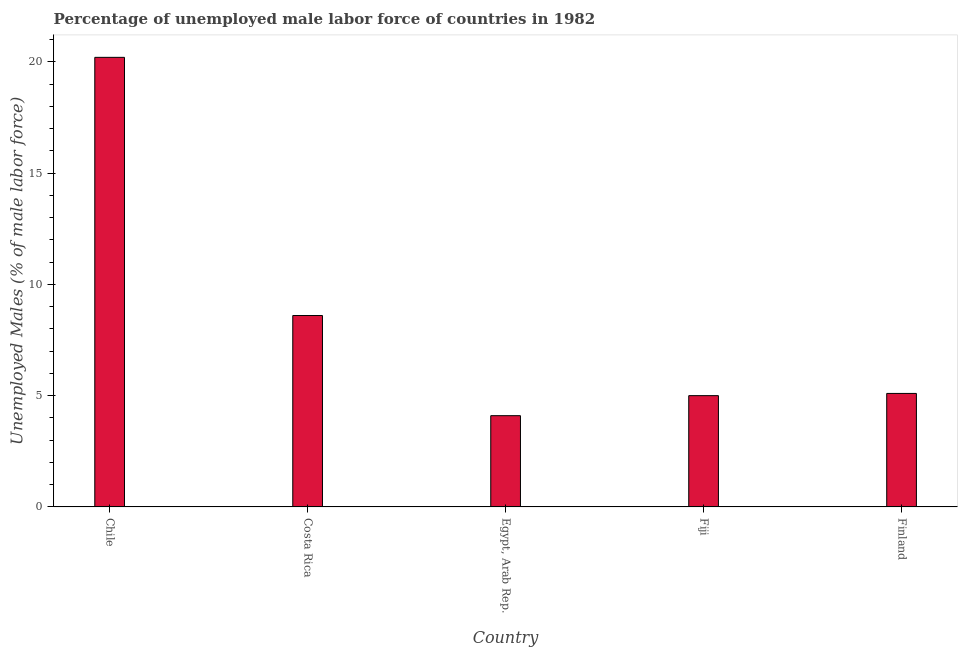Does the graph contain any zero values?
Offer a terse response. No. What is the title of the graph?
Provide a succinct answer. Percentage of unemployed male labor force of countries in 1982. What is the label or title of the X-axis?
Give a very brief answer. Country. What is the label or title of the Y-axis?
Make the answer very short. Unemployed Males (% of male labor force). What is the total unemployed male labour force in Finland?
Your answer should be compact. 5.1. Across all countries, what is the maximum total unemployed male labour force?
Your answer should be compact. 20.2. Across all countries, what is the minimum total unemployed male labour force?
Offer a very short reply. 4.1. In which country was the total unemployed male labour force minimum?
Keep it short and to the point. Egypt, Arab Rep. What is the sum of the total unemployed male labour force?
Keep it short and to the point. 43. What is the difference between the total unemployed male labour force in Chile and Egypt, Arab Rep.?
Give a very brief answer. 16.1. What is the average total unemployed male labour force per country?
Offer a terse response. 8.6. What is the median total unemployed male labour force?
Make the answer very short. 5.1. In how many countries, is the total unemployed male labour force greater than 6 %?
Provide a short and direct response. 2. What is the ratio of the total unemployed male labour force in Chile to that in Egypt, Arab Rep.?
Provide a succinct answer. 4.93. Is the difference between the total unemployed male labour force in Costa Rica and Fiji greater than the difference between any two countries?
Your answer should be very brief. No. Are all the bars in the graph horizontal?
Your answer should be compact. No. Are the values on the major ticks of Y-axis written in scientific E-notation?
Make the answer very short. No. What is the Unemployed Males (% of male labor force) of Chile?
Offer a terse response. 20.2. What is the Unemployed Males (% of male labor force) in Costa Rica?
Give a very brief answer. 8.6. What is the Unemployed Males (% of male labor force) in Egypt, Arab Rep.?
Your response must be concise. 4.1. What is the Unemployed Males (% of male labor force) in Finland?
Make the answer very short. 5.1. What is the difference between the Unemployed Males (% of male labor force) in Chile and Costa Rica?
Offer a very short reply. 11.6. What is the difference between the Unemployed Males (% of male labor force) in Chile and Egypt, Arab Rep.?
Give a very brief answer. 16.1. What is the difference between the Unemployed Males (% of male labor force) in Chile and Fiji?
Provide a short and direct response. 15.2. What is the difference between the Unemployed Males (% of male labor force) in Costa Rica and Egypt, Arab Rep.?
Your answer should be compact. 4.5. What is the difference between the Unemployed Males (% of male labor force) in Fiji and Finland?
Offer a very short reply. -0.1. What is the ratio of the Unemployed Males (% of male labor force) in Chile to that in Costa Rica?
Give a very brief answer. 2.35. What is the ratio of the Unemployed Males (% of male labor force) in Chile to that in Egypt, Arab Rep.?
Make the answer very short. 4.93. What is the ratio of the Unemployed Males (% of male labor force) in Chile to that in Fiji?
Keep it short and to the point. 4.04. What is the ratio of the Unemployed Males (% of male labor force) in Chile to that in Finland?
Your answer should be very brief. 3.96. What is the ratio of the Unemployed Males (% of male labor force) in Costa Rica to that in Egypt, Arab Rep.?
Give a very brief answer. 2.1. What is the ratio of the Unemployed Males (% of male labor force) in Costa Rica to that in Fiji?
Offer a very short reply. 1.72. What is the ratio of the Unemployed Males (% of male labor force) in Costa Rica to that in Finland?
Offer a very short reply. 1.69. What is the ratio of the Unemployed Males (% of male labor force) in Egypt, Arab Rep. to that in Fiji?
Keep it short and to the point. 0.82. What is the ratio of the Unemployed Males (% of male labor force) in Egypt, Arab Rep. to that in Finland?
Your answer should be very brief. 0.8. What is the ratio of the Unemployed Males (% of male labor force) in Fiji to that in Finland?
Make the answer very short. 0.98. 